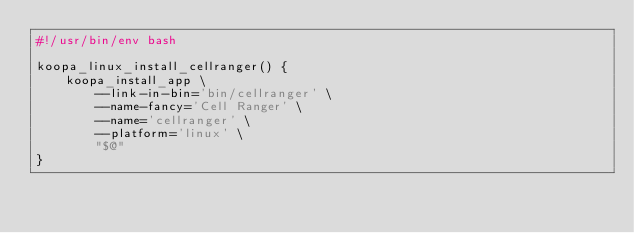<code> <loc_0><loc_0><loc_500><loc_500><_Bash_>#!/usr/bin/env bash

koopa_linux_install_cellranger() {
    koopa_install_app \
        --link-in-bin='bin/cellranger' \
        --name-fancy='Cell Ranger' \
        --name='cellranger' \
        --platform='linux' \
        "$@"
}
</code> 